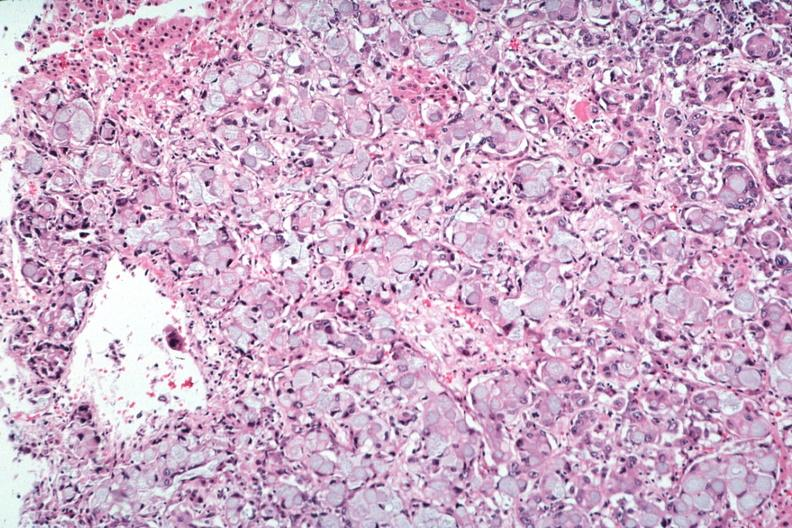s situs inversus present?
Answer the question using a single word or phrase. No 